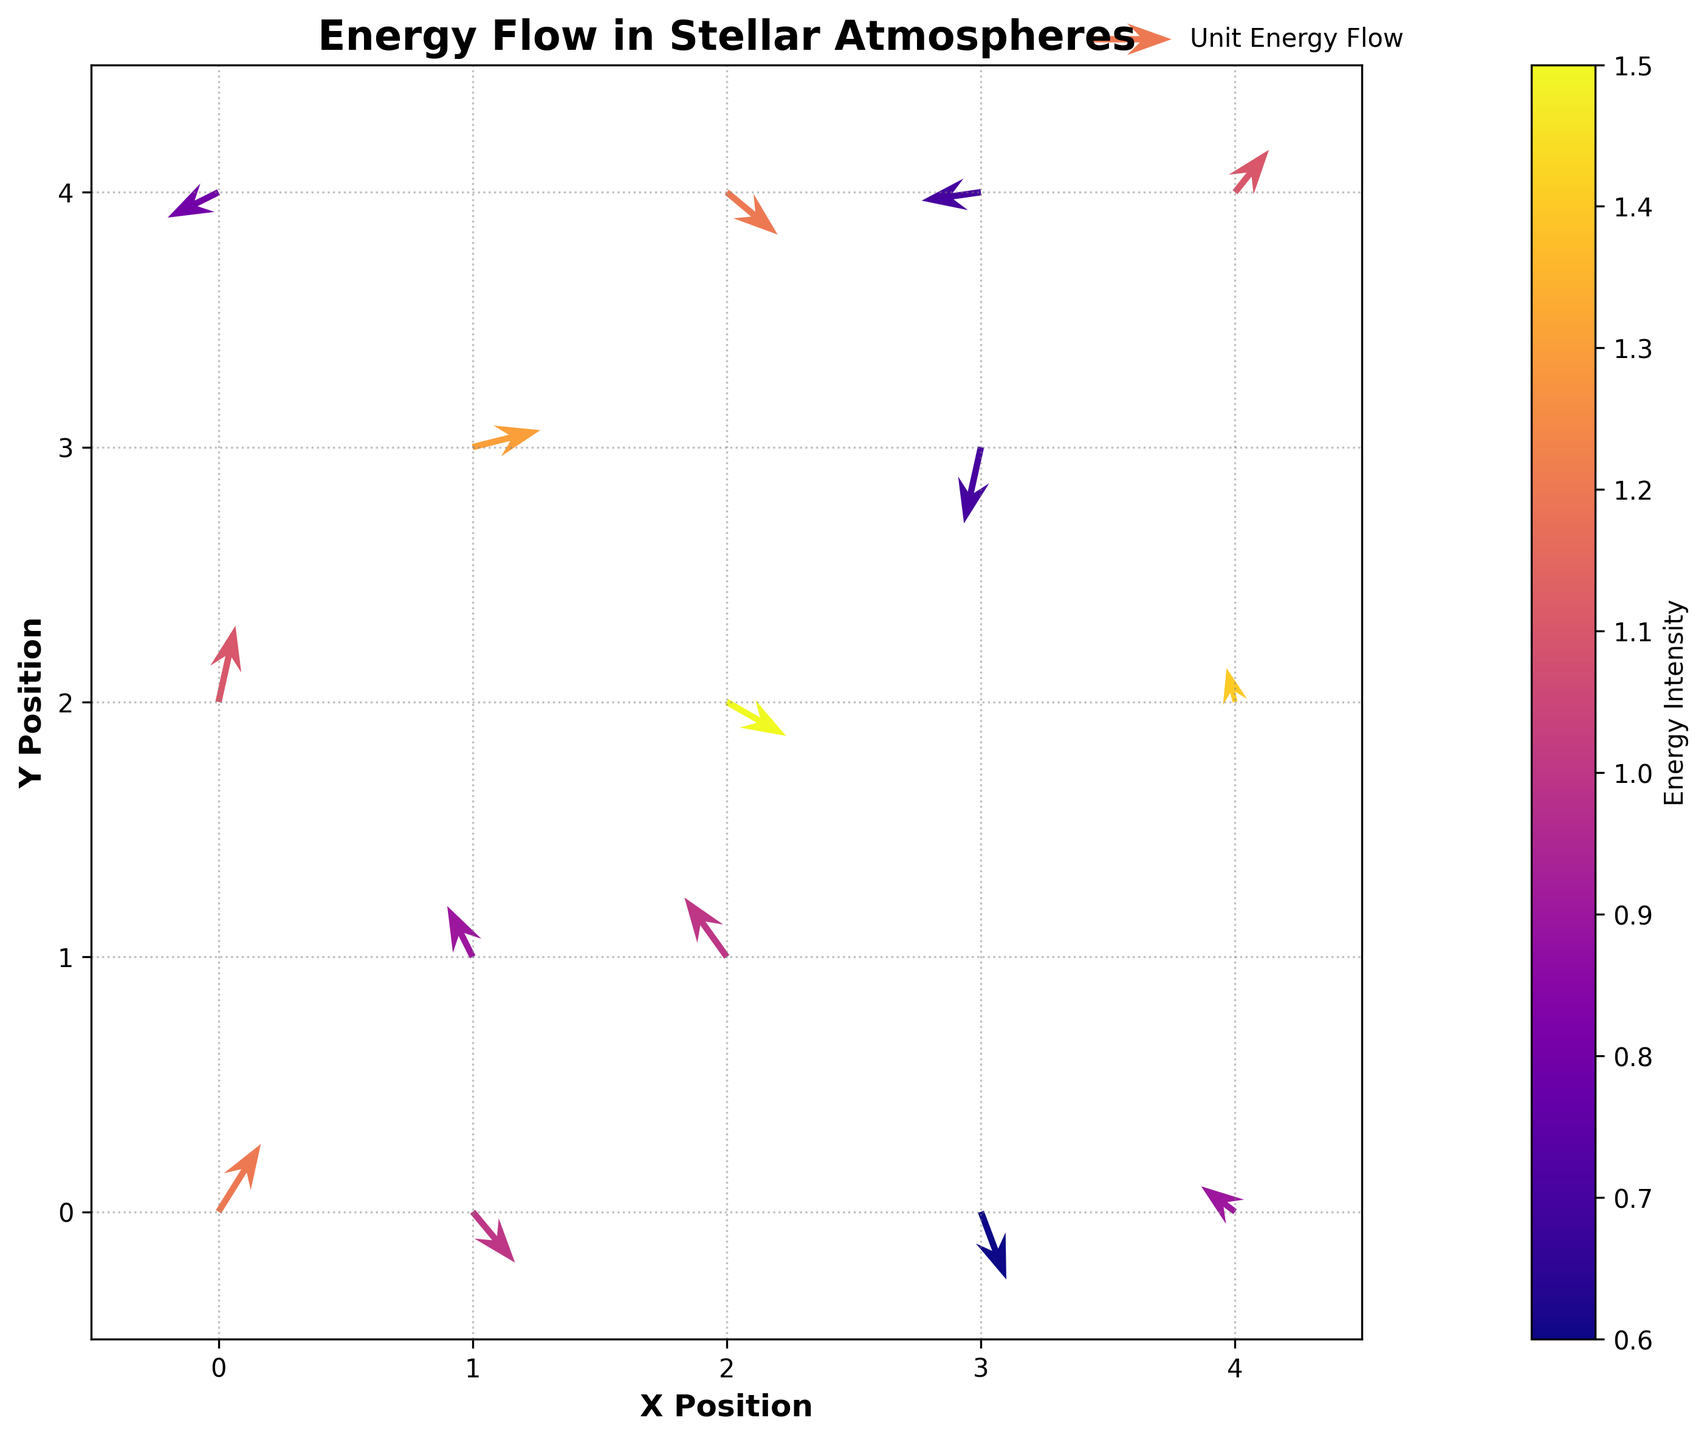What is the title of the figure? The title of the figure is often placed at the top of the plot and is written in bold text. In this case, the title is "Energy Flow in Stellar Atmospheres."
Answer: Energy Flow in Stellar Atmospheres How many data points are present in the plot? To find the number of data points, we can count the number of arrows in the quiver plot. Each arrow represents a single data point. By visually inspecting the plot, we see that there are 15 arrows.
Answer: 15 What is the color of the arrow with the highest energy intensity? The arrow with the highest energy intensity is colored according to the color map used in the plot. By observing the color bar, we identify that the highest intensity corresponds to a color at the extreme end of the spectrum, which, in this case, is the 'plasma' color map. The highest intensity will have a purple color.
Answer: Purple What is the direction of energy flow at the point (0, 0)? At the point (0, 0), we look at the arrow originating from this position. The arrow points in the direction of energy flow, which is given by the vector (u, v). Specifically, at (0, 0), the vector is (0.5, 0.8) indicating a direction going northeast.
Answer: Northeast Which data point has the smallest energy intensity? The smallest energy intensity can be identified by looking at the color bar and finding the arrow with the color closest to the minimum end of the spectrum. In this case, the color closest to this end is pale yellow, which corresponds to the intensity value of 0.6 at the point (3, 0).
Answer: (3, 0) What is the average intensity of the energy flow in the stellar atmosphere? To calculate the average intensity, sum all the intensities and divide by the number of data points. The total intensity is 1.2 + 0.9 + 1.5 + 0.7 + 1.1 + 0.8 + 1.3 + 1.0 + 0.6 + 1.4 + 1.2 + 0.9 + 1.1 + 0.7 + 1.0, which equals 16.4. There are 15 points, so the average intensity is 16.4 / 15.
Answer: 1.09 What is the predominant direction of energy flow for points along the y-axis? To determine this, we examine the arrows positioned along the y-axis at x=0. From (0, 4), (0, 2), and (0, 0), the directions are given by vectors (-0.6, -0.3), (0.2, 0.9), and (0.5, 0.8), respectively. Most arrows point upwards (along the positive y-direction).
Answer: Upwards Which location has an energy flow vector that changes direction compared to the neighboring point on the same row? To identify this, we compare the direction of vectors within the same row. Notably, at points (2, 2) and (3, 3), the vector directions change from (0.7, -0.4) to (-0.2, -0.9), indicating a significant change in direction.
Answer: (2, 2) and (3, 3) What is the net horizontal energy flow (x-axis) in the plot? The net horizontal energy flow can be found by summing all the horizontal components (u values) of the vectors: 0.5 - 0.3 + 0.7 - 0.2 + 0.4 - 0.6 + 0.8 - 0.5 + 0.3 - 0.1 + 0.6 - 0.4 + 0.2 - 0.7 + 0.5, which equals 0.7.
Answer: 0.7 